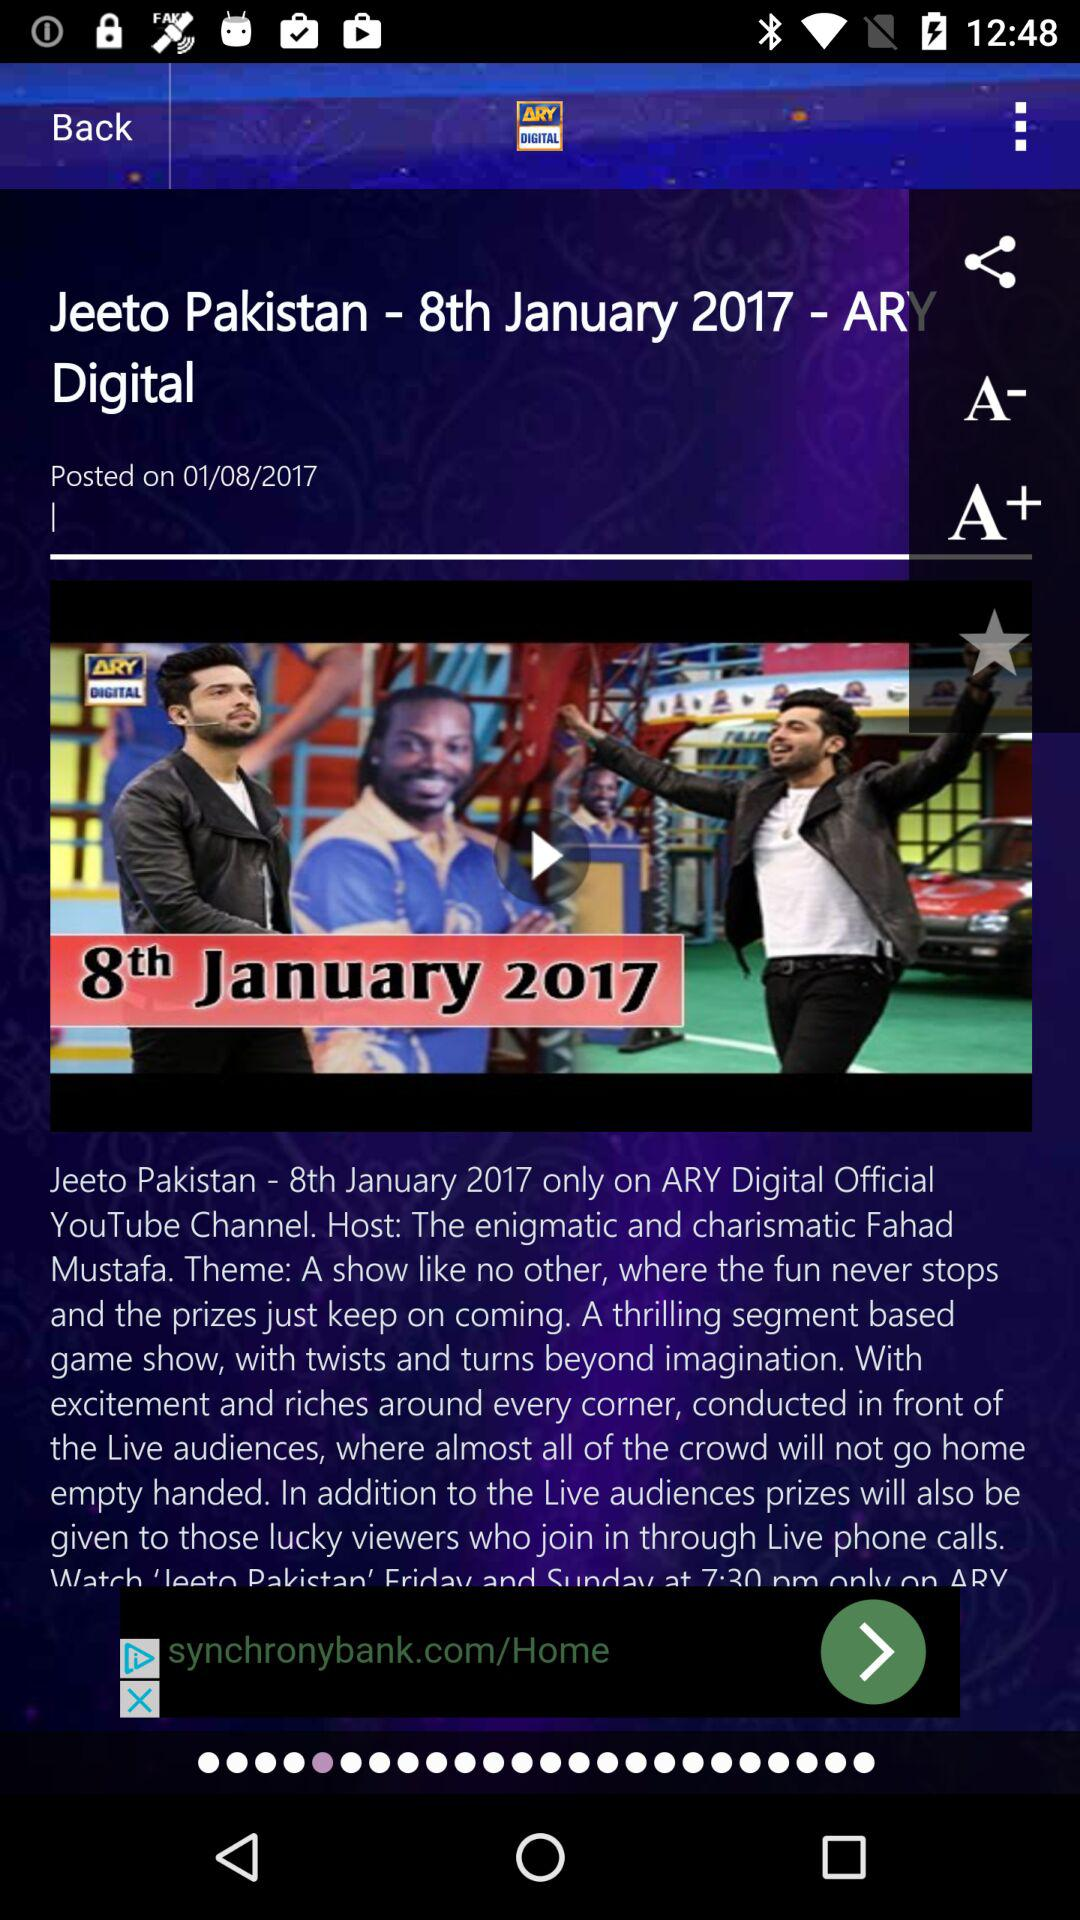When was "Jeeto Pakistan - 8th January 2017 - ARY Digital" posted? "Jeeto Pakistan - 8th January 2017 - ARY Digital" was posted on January 8, 2017. 